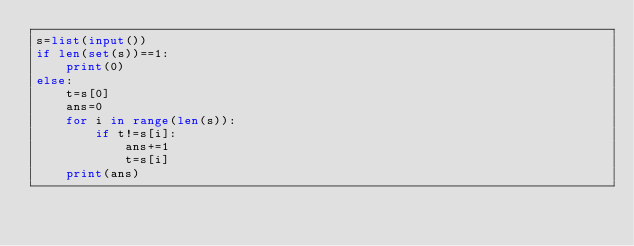<code> <loc_0><loc_0><loc_500><loc_500><_Python_>s=list(input())
if len(set(s))==1:
    print(0)
else:
    t=s[0]
    ans=0
    for i in range(len(s)):
        if t!=s[i]:
            ans+=1
            t=s[i]
    print(ans)</code> 